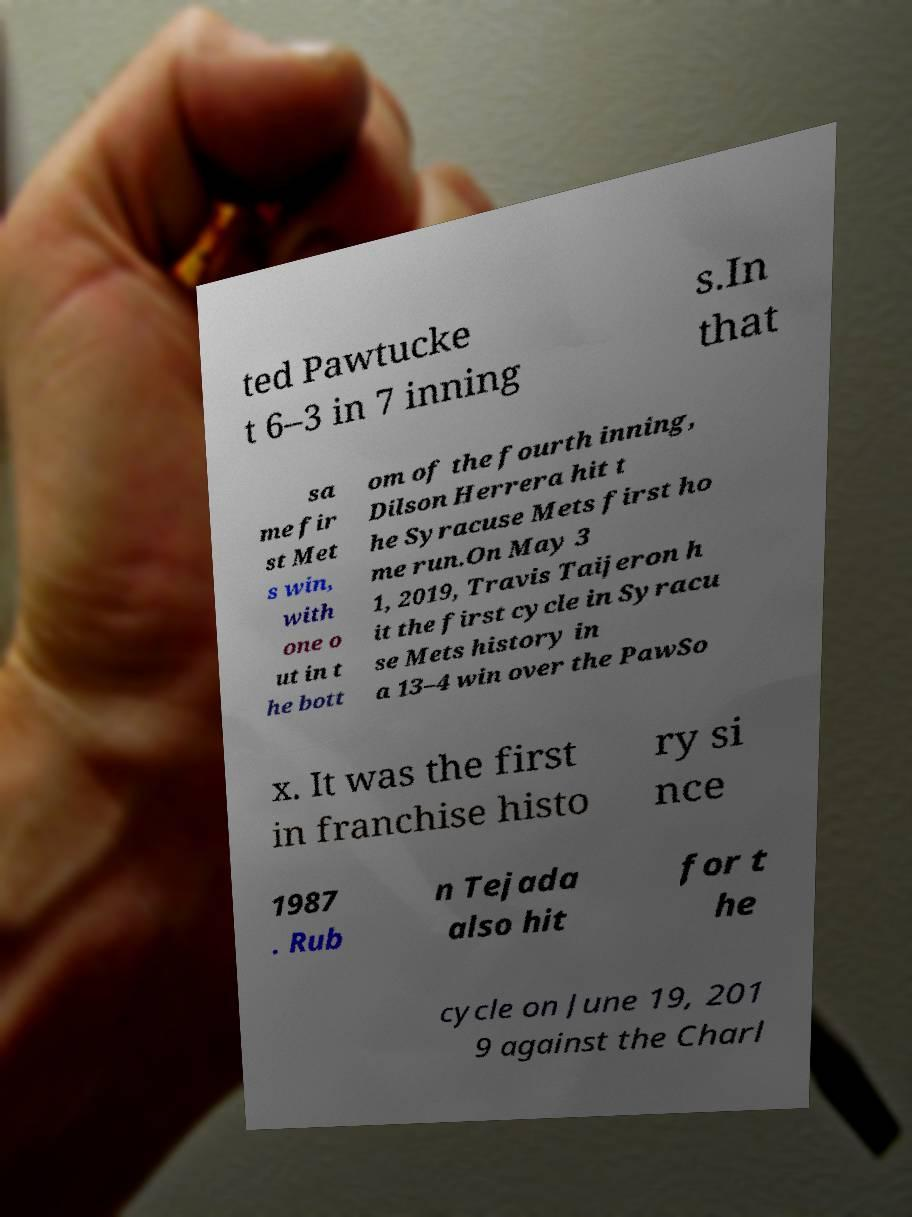For documentation purposes, I need the text within this image transcribed. Could you provide that? ted Pawtucke t 6–3 in 7 inning s.In that sa me fir st Met s win, with one o ut in t he bott om of the fourth inning, Dilson Herrera hit t he Syracuse Mets first ho me run.On May 3 1, 2019, Travis Taijeron h it the first cycle in Syracu se Mets history in a 13–4 win over the PawSo x. It was the first in franchise histo ry si nce 1987 . Rub n Tejada also hit for t he cycle on June 19, 201 9 against the Charl 